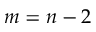<formula> <loc_0><loc_0><loc_500><loc_500>m = n - 2</formula> 